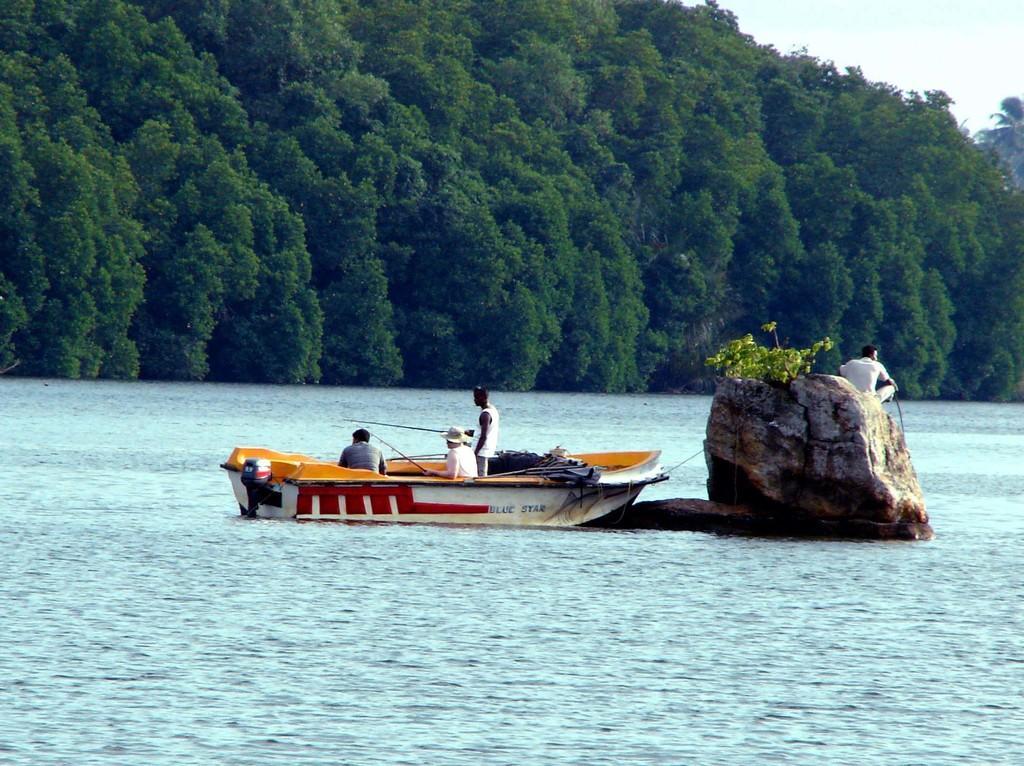Can you describe this image briefly? In this image there is a boat in the center and the persons inside it sitting and standing. On the right side of the boat there is a man sitting on the stone. In the background there are mountains. In the front there is a water. 